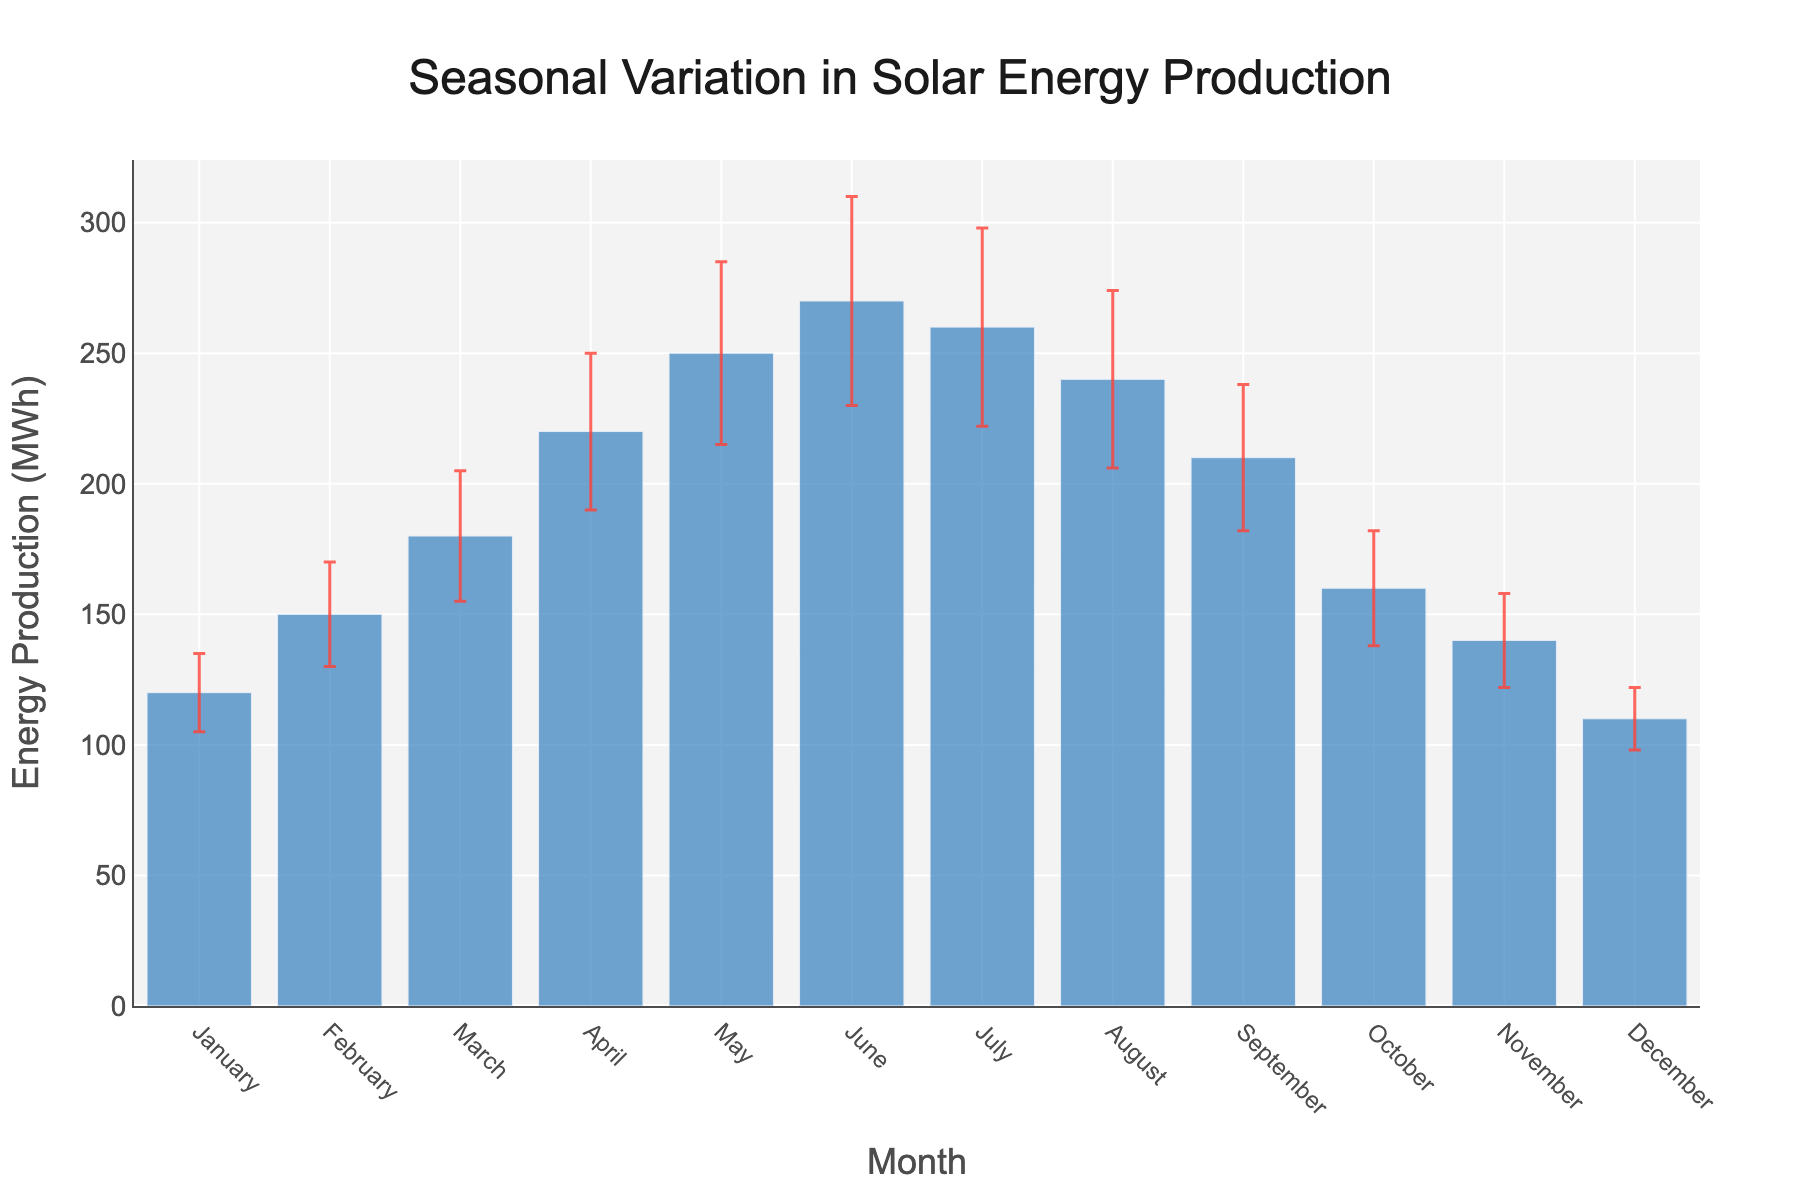What's the title of the figure? The title of the figure is displayed at the top and centered. It reads "Seasonal Variation in Solar Energy Production".
Answer: Seasonal Variation in Solar Energy Production What is the x-axis labeling? The x-axis labeling represents the twelve months of the year, from January to December.
Answer: Months What is the average solar energy production for June? Find the bar corresponding to June and read the y-axis value. The average solar energy production for June is 270 MWh.
Answer: 270 MWh During which month is the standard deviation the highest? Check the error bars across all months and find the month with the longest error bar. The highest standard deviation occurs in June with a value of 40 MWh.
Answer: June What is the difference in average solar energy production between May and February? Subtract the average energy production of February from that of May. May's production is 250 MWh and February's is 150 MWh, which gives a difference of 250 - 150 = 100 MWh.
Answer: 100 MWh Which month shows the lowest average solar energy production and what is its standard deviation? Identify the shortest bar and then check the corresponding standard deviation. December has the lowest average production of 110 MWh with a standard deviation of 12 MWh.
Answer: December, 12 MWh What is the average solar energy production in the first half (January to June) of the year? Sum up the average productions from January to June and divide by 6. (120 + 150 + 180 + 220 + 250 + 270) / 6 = 1190 / 6 = 198.33 MWh.
Answer: 198.33 MWh Which month shows a decline in average solar energy production compared to the previous month? Compare the heights of consecutive bars to find where a decrease appears. July shows a decline compared to June, from 270 MWh to 260 MWh.
Answer: July How do the average solar energy productions of the months with the highest and lowest production compare? Identify the month with the highest production (June, 270 MWh) and the lowest (December, 110 MWh) and state the difference. 270 MWh - 110 MWh = 160 MWh.
Answer: 160 MWh What can be inferred about the seasonal trend in solar energy production? Considering the highest values occur around the middle of the year (April to July) and the lowest values in winter (December to February), it can be inferred that solar energy production is highest in late spring to mid-summer and lowest in winter.
Answer: Production peaks in late spring to mid-summer and is lowest in winter 